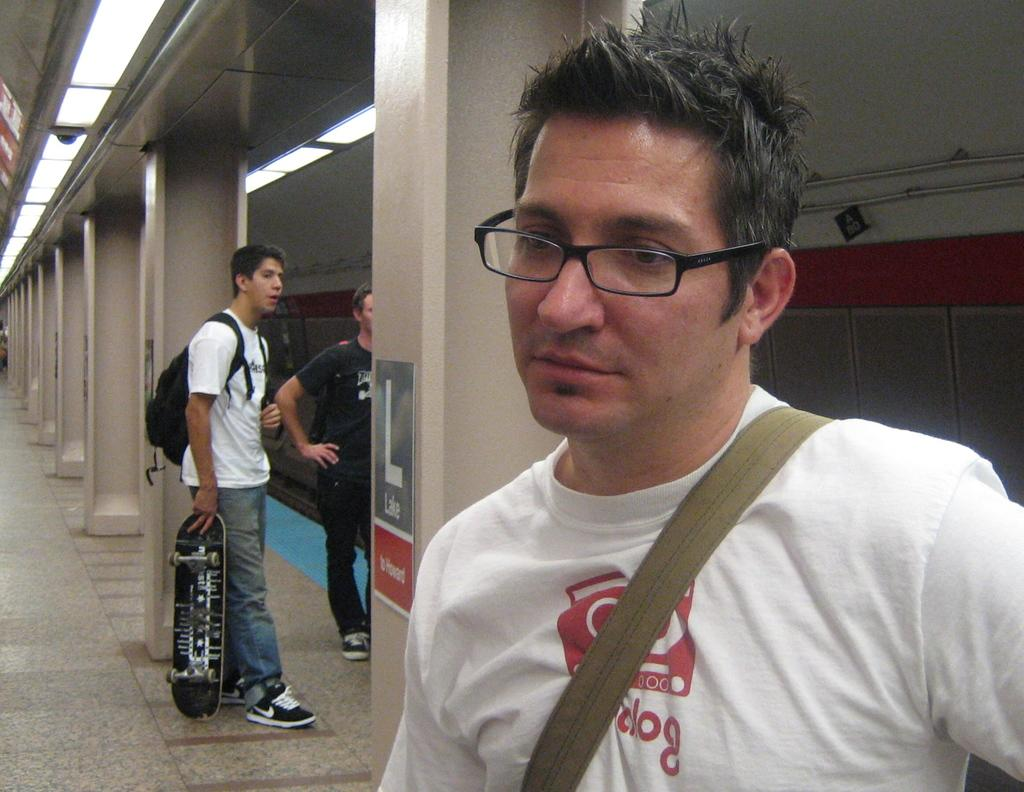How many people are in the image? There are three people in the image. What is one person doing in the image? One person is holding a skateboard. What is the person holding the skateboard wearing? The person holding the skateboard is wearing a backpack. What can be seen in the background of the image? In the background of the image, there are pillars, the floor, glass, lights, and pipes. What type of meal is being prepared by the person in the image? There is no indication in the image that a meal is being prepared, as the focus is on the people and their activities. 